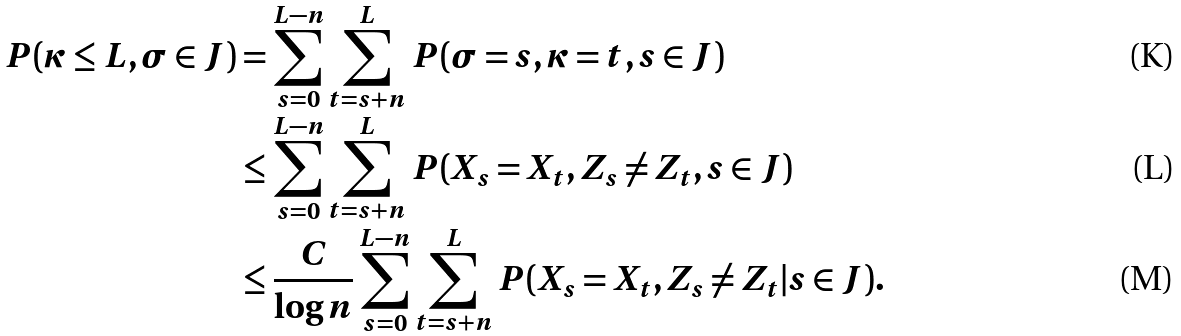Convert formula to latex. <formula><loc_0><loc_0><loc_500><loc_500>P ( \kappa \leq L , \sigma \in J ) & = \sum _ { s = 0 } ^ { L - n } \sum _ { t = s + n } ^ { L } P ( \sigma = s , \kappa = t , s \in J ) \\ & \leq \sum _ { s = 0 } ^ { L - n } \sum _ { t = s + n } ^ { L } P ( X _ { s } = X _ { t } , Z _ { s } \neq Z _ { t } , s \in J ) \\ & \leq \frac { C } { \log n } \sum _ { s = 0 } ^ { L - n } \sum _ { t = s + n } ^ { L } P ( X _ { s } = X _ { t } , Z _ { s } \neq Z _ { t } | s \in J ) .</formula> 